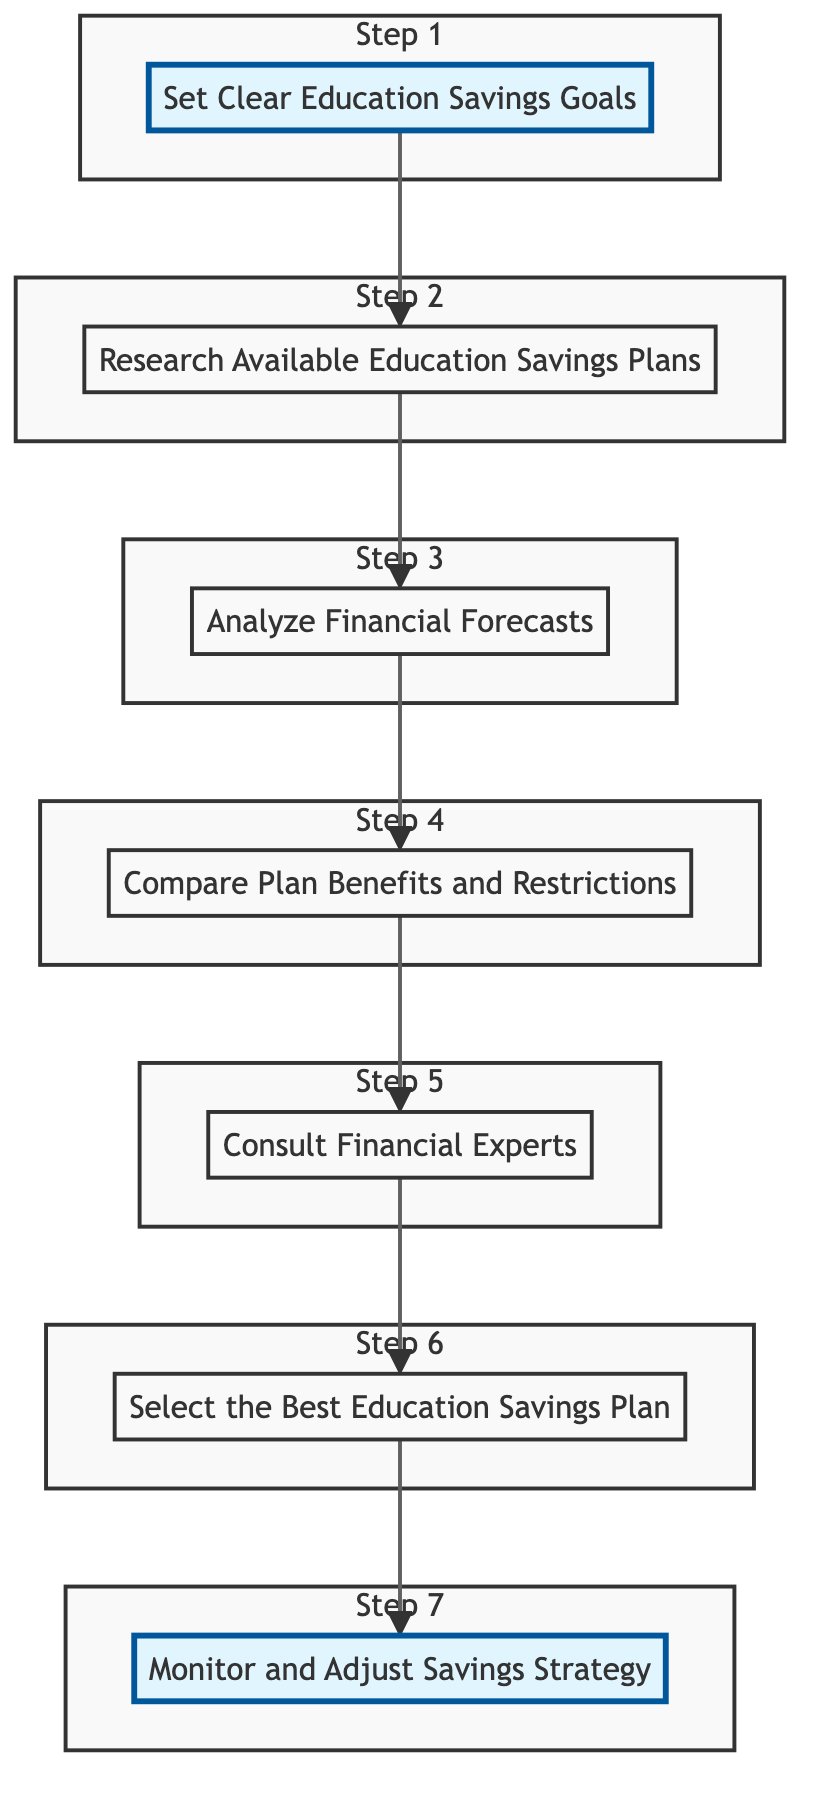What is the first step in the flow chart? The first step in the flow chart is labeled "Set Clear Education Savings Goals". This can be identified as the starting node at the top of the diagram.
Answer: Set Clear Education Savings Goals How many steps are there in total? By counting the nodes in the flow chart, there are seven individual steps outlined.
Answer: 7 What action follows "Analyze Financial Forecasts"? The action that follows "Analyze Financial Forecasts" is "Compare Plan Benefits and Restrictions". This can be determined by looking at the arrows connecting the nodes.
Answer: Compare Plan Benefits and Restrictions Which step involves consultation with experts? The step that involves consultation with experts is "Consult Financial Experts". This step is located after evaluating comparisons in the flow.
Answer: Consult Financial Experts What is the last action in the flow chart? The last action in the flow chart is "Monitor and Adjust Savings Strategy". This can be identified as the final node connected in the sequence.
Answer: Monitor and Adjust Savings Strategy Which step directly precedes the selection of a plan? The step that directly precedes the selection of a plan is "Consult Financial Experts". This can be deduced from the sequence of steps leading to the selection.
Answer: Consult Financial Experts What should you do after selecting the best education savings plan? After selecting the best education savings plan, you should "Monitor and Adjust Savings Strategy". This follows logically as the final step in the evaluation process.
Answer: Monitor and Adjust Savings Strategy Identify one detail from the "Research Available Education Savings Plans" step. The detail from the "Research Available Education Savings Plans" step is "Look into 529 Plans, Coverdell ESAs, and Custodial Accounts." This is the explanatory text associated with that step.
Answer: Look into 529 Plans, Coverdell ESAs, and Custodial Accounts 